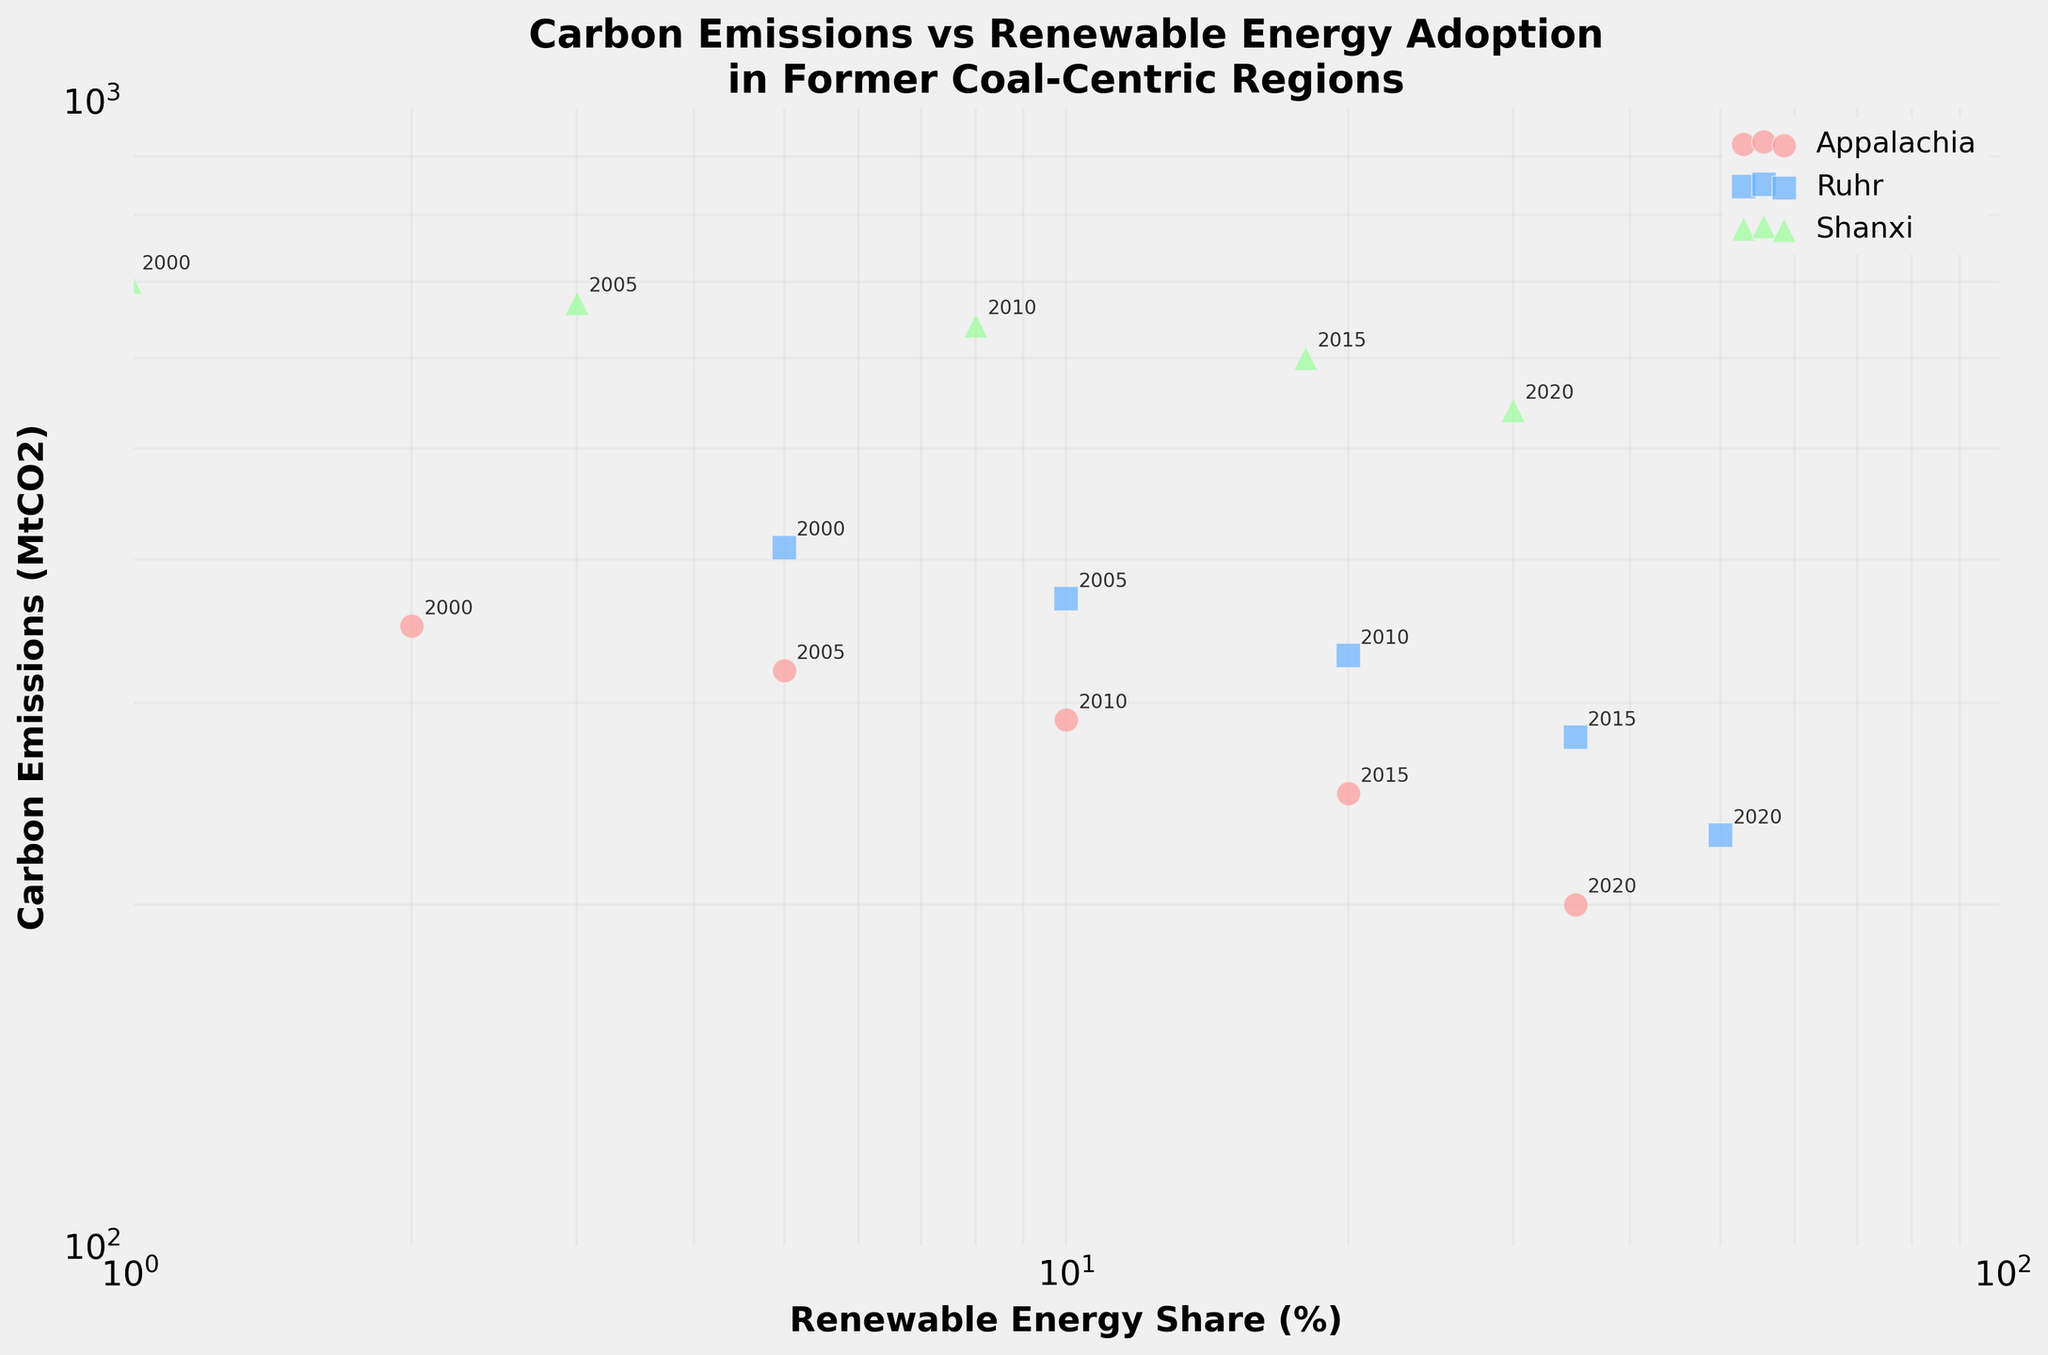How many regions are represented in the figure? There are three distinct regions represented in the scatter plot as indicated by the different colors and markers.
Answer: 3 Which region had the highest Carbon Emissions in 2020? In 2020, the highest Carbon Emissions data point (540 MtCO2) corresponds with the "Shanxi" region, which has the largest value among the three regions for that year.
Answer: Shanxi How does the share of renewable energy in Appalachia change from 2000 to 2020? In 2000, Appalachia has a share of 2%, and in 2020, it reaches 35%. The change is calculated as 35% - 2% = 33%.
Answer: Increased by 33% In which region and year was the share of renewable energy exactly 10%? Reviewing the data points with associated labels, "Ruhr" in 2005 and "Appalachia" in 2010 both had a renewable energy share of 10%.
Answer: Ruhr 2005 and Appalachia 2010 What is the percentage decrease in Carbon Emissions in the Ruhr region from 2000 to 2020? Carbon Emissions in Ruhr were 410 MtCO2 in 2000 and 230 MtCO2 in 2020. The percentage decrease is ((410 - 230) / 410) * 100 ≈ 43.9%.
Answer: 43.9% Which region shows the highest log-scaled increase in renewable energy share from 2000 to 2020? Calculating the ratios: Appalachia (35/2), Ruhr (50/5), Shanxi (30/1). Log-scaled increase is higher for Shanxi as 30/1 = 30.
Answer: Shanxi Compare the Carbon Emissions of Shanxi between 2005 and 2020. How much did it decrease? Shanxi's Carbon Emissions were 670 MtCO2 in 2005 and 540 MtCO2 in 2020. The decrease is 670 - 540 = 130 MtCO2.
Answer: Decreased by 130 MtCO2 Does any region show a reduction of more than 100 MtCO2 in emissions from 2015 to 2020? Comparing emissions in 2015 and 2020: Shanxi drops from 600 to 540, a decrease of 60 MtCO2. Appalachia drops from 250 to 200, a decrease of 50 MtCO2. Ruhr drops from 280 to 230, a decrease of 50 MtCO2. No region shows a reduction greater than 60 MtCO2.
Answer: No 